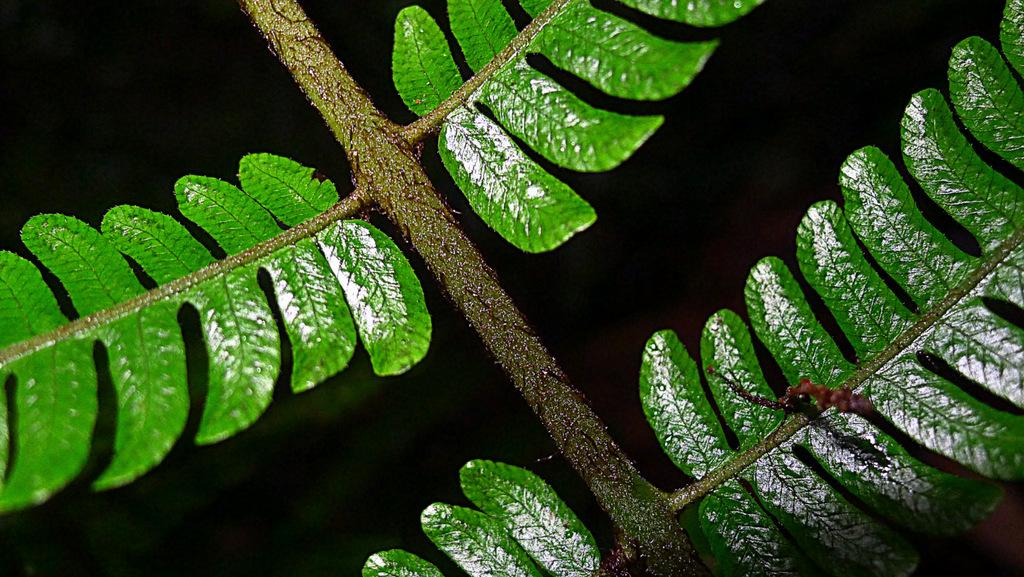What is the main subject of the image? The main subject of the image is a stem. What is attached to the stem? There are leaves in the image that are attached to the stem. What can be observed about the background of the image? The background of the image is dark. What type of secretary can be seen working in the image? There is no secretary present in the image; it features a stem and leaves. Is there a jail visible in the image? There is no jail present in the image; it features a stem and leaves. 